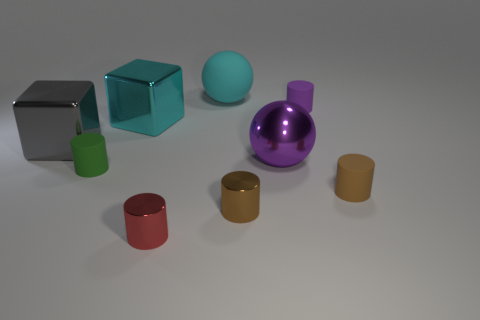Do the tiny brown matte thing and the big shiny thing to the right of the tiny red cylinder have the same shape?
Provide a short and direct response. No. There is a cyan ball behind the tiny red shiny cylinder; is its size the same as the metal cylinder left of the large rubber thing?
Your answer should be very brief. No. Are there any tiny cylinders that are behind the big cyan metallic thing that is behind the big object that is on the left side of the small green thing?
Your answer should be very brief. Yes. Are there fewer small purple matte cylinders behind the red metallic cylinder than objects that are behind the gray thing?
Your response must be concise. Yes. What shape is the green thing that is the same material as the tiny purple object?
Ensure brevity in your answer.  Cylinder. There is a purple metal sphere on the left side of the small purple matte cylinder behind the brown cylinder that is right of the big purple metal sphere; how big is it?
Offer a terse response. Large. Is the number of small green matte things greater than the number of blue metal objects?
Your answer should be very brief. Yes. Is the color of the rubber cylinder to the right of the small purple rubber cylinder the same as the rubber cylinder that is left of the big cyan block?
Make the answer very short. No. Are the big ball that is behind the purple ball and the small object that is right of the purple rubber cylinder made of the same material?
Provide a succinct answer. Yes. How many green matte objects are the same size as the brown metal thing?
Make the answer very short. 1. 